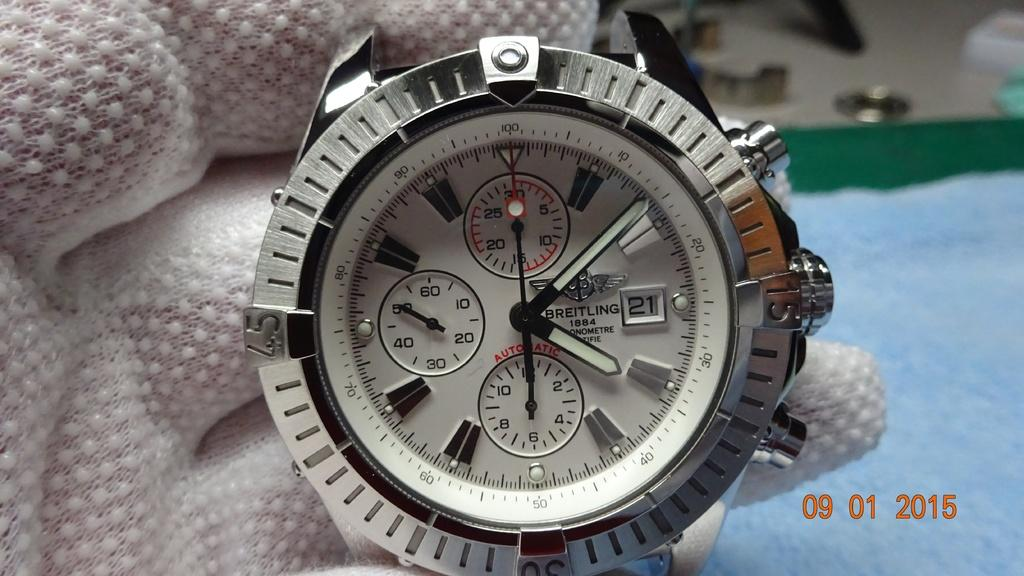<image>
Write a terse but informative summary of the picture. A silver and white Breitling analog watch showing 4:08. 